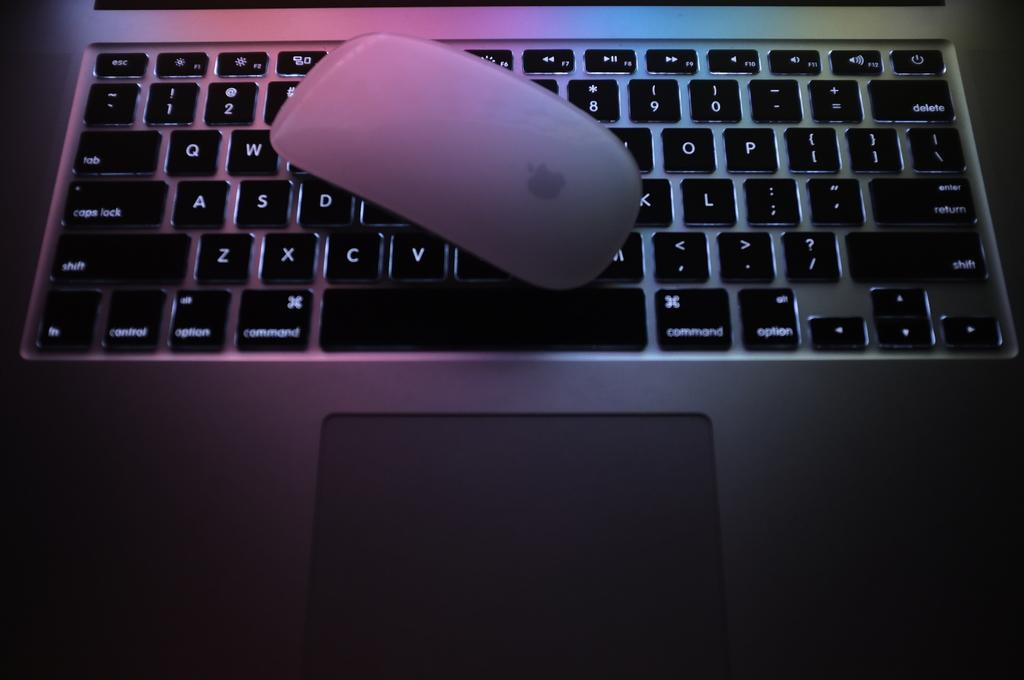<image>
Share a concise interpretation of the image provided. Someone has placed a Mac mouse over a keyboard right next to the V key. 